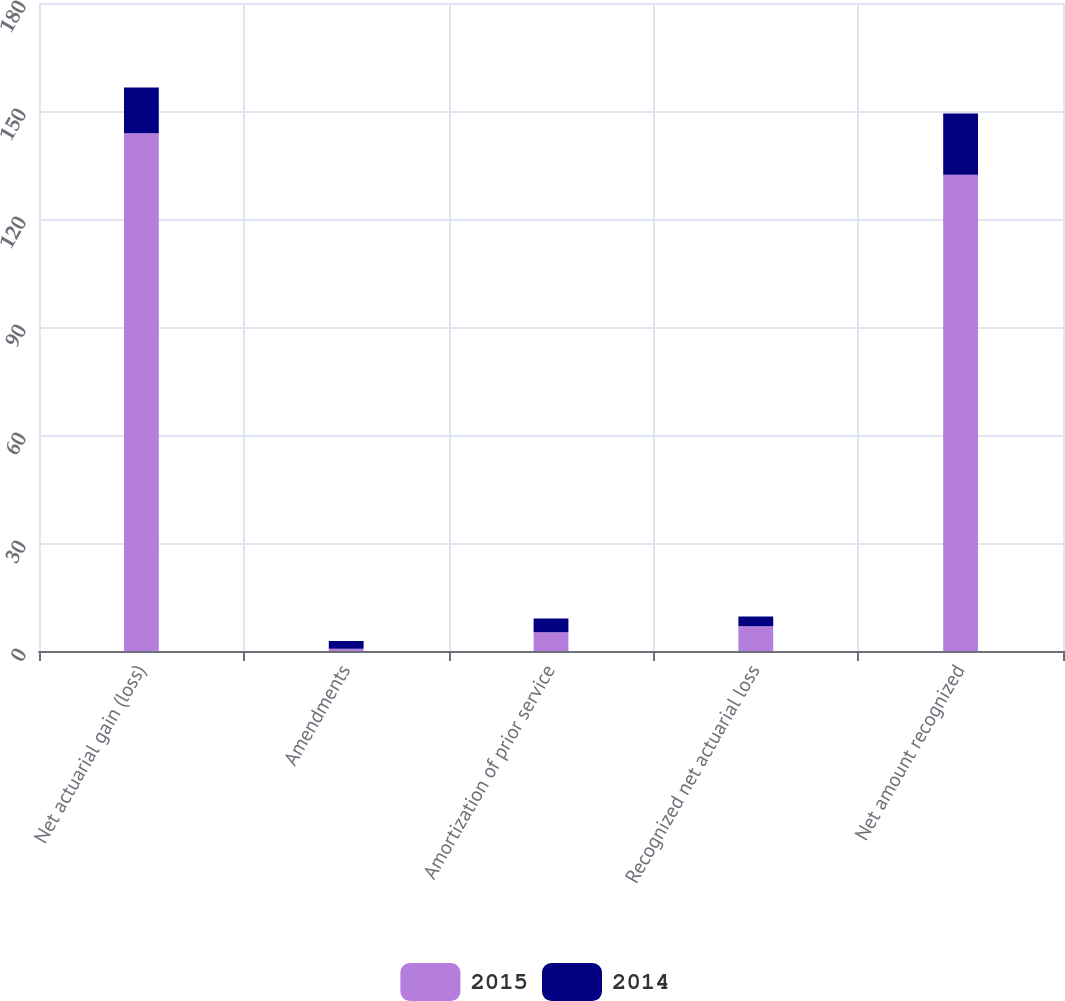Convert chart to OTSL. <chart><loc_0><loc_0><loc_500><loc_500><stacked_bar_chart><ecel><fcel>Net actuarial gain (loss)<fcel>Amendments<fcel>Amortization of prior service<fcel>Recognized net actuarial loss<fcel>Net amount recognized<nl><fcel>2015<fcel>143.8<fcel>0.6<fcel>5.2<fcel>6.9<fcel>132.3<nl><fcel>2014<fcel>12.7<fcel>2.2<fcel>3.8<fcel>2.7<fcel>17<nl></chart> 